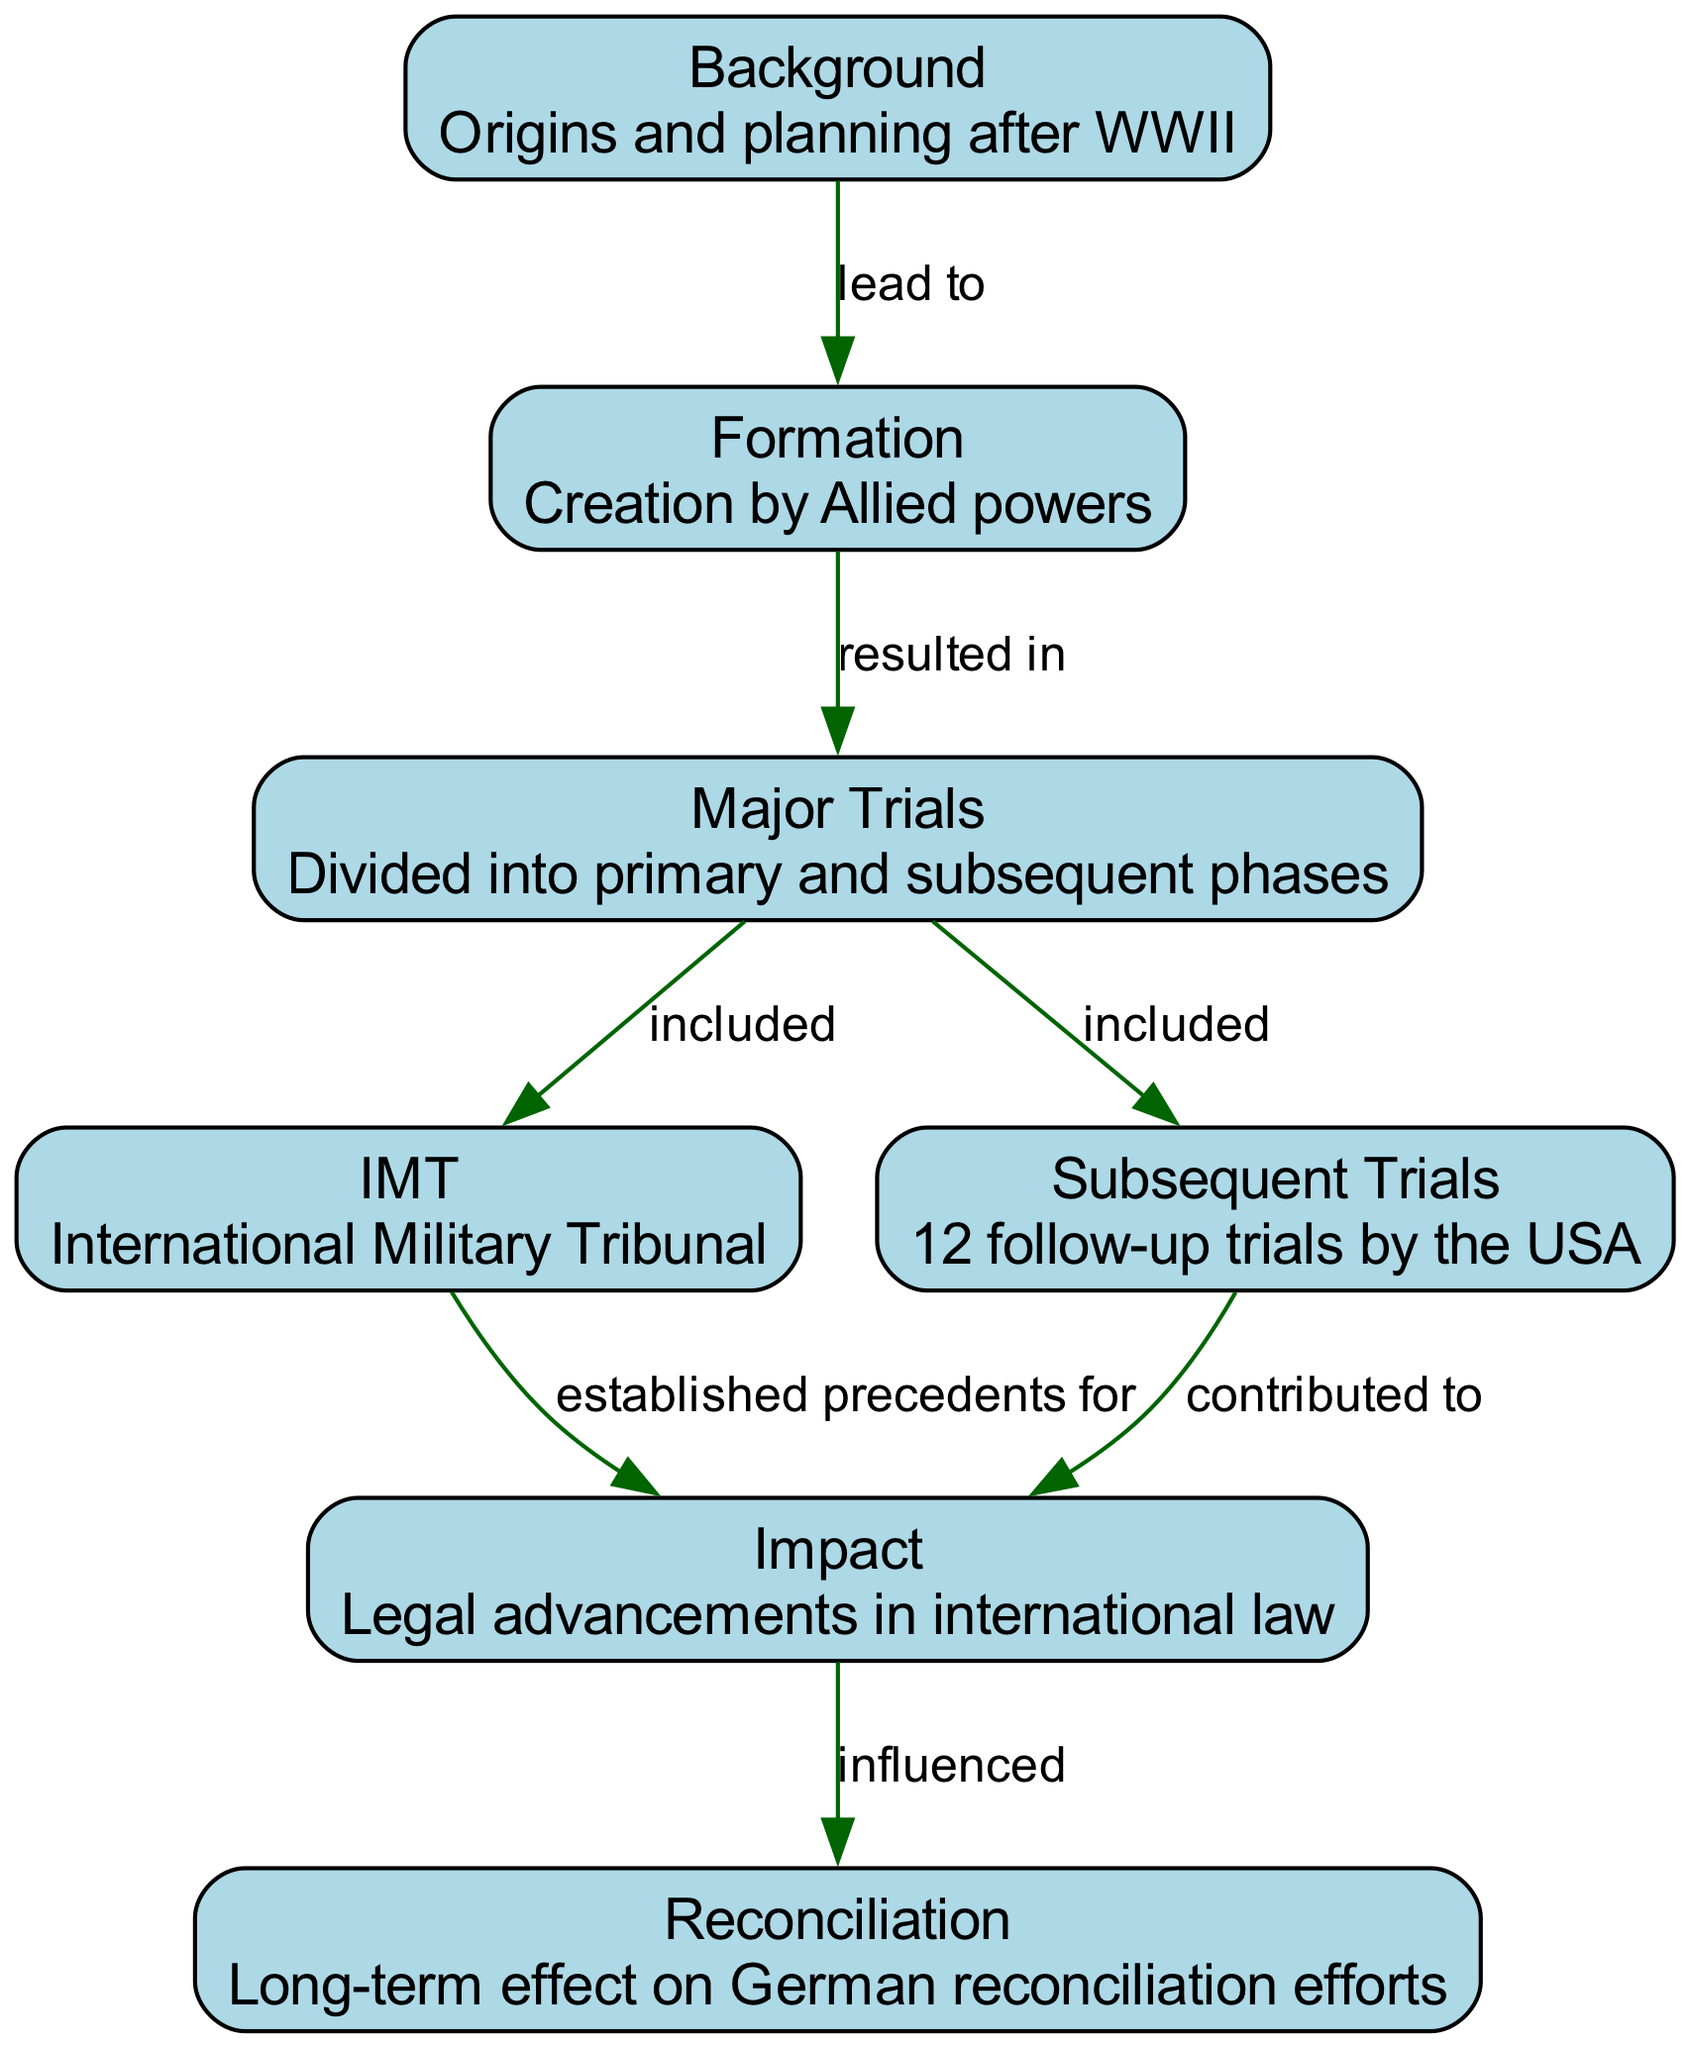What is the first node in the diagram? The first node can be identified in the diagram as "Background". It is the initial point from which the rest of the diagram flows.
Answer: Background How many nodes are present in the diagram? By counting the individual node entries in the diagram data, we can confirm that there are a total of 7 nodes present.
Answer: 7 What is the relationship between "Formation" and "Major Trials"? The relationship is defined as "resulted in", indicating that "Formation" directly leads to "Major Trials". This can be traced through the directed edge from node 2 to node 3 in the diagram.
Answer: resulted in Which trial is mentioned in the "Major Trials" node? The "Major Trials" node specifically includes the "IMT" as one of its components, indicating its significance in the proceedings.
Answer: IMT What did the "IMT" establish precedents for? The "IMT" established precedents for "legal advancements in international law", as denoted by the edge from node 4 to node 6.
Answer: legal advancements in international law How are the "Subsequent Trials" connected to the overall impact of the trials? The "Subsequent Trials" contributed to "legal advancements in international law", showcasing their importance in the broader impact outlined in the diagram. This is noted from the relationship between node 5 and node 6.
Answer: contributed to What long-term effect is indicated in the diagram as a result of the trials? The long-term effect highlighted in the diagram is its influence on "German reconciliation efforts", linking the impact of the trials directly to reconciliation.
Answer: German reconciliation efforts What is the main focus of the "Background" node? The "Background" node focuses on the "origins and planning after WWII", providing context for why these trials were initiated.
Answer: origins and planning after WWII Which node is at the end of the flow indicating influence? The endpoint of the flow indicating influence is the "Reconciliation" node, showing the ultimate outcome of the trials depicted throughout the diagram.
Answer: Reconciliation 